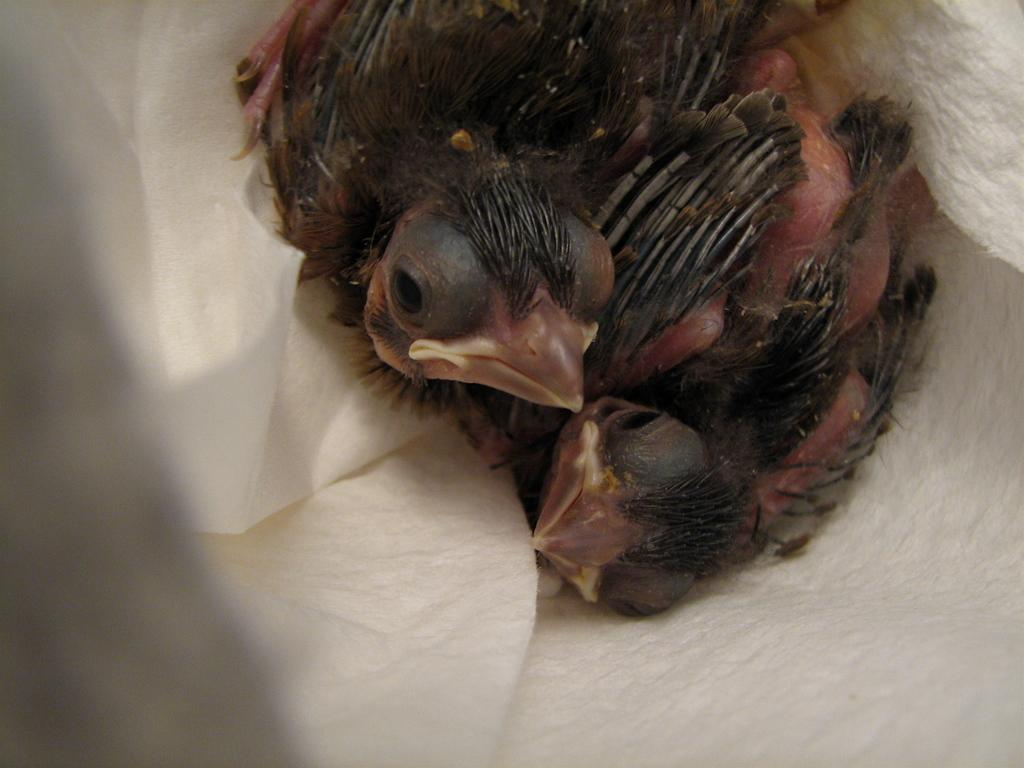What type of animal is in the image? There is a bird in the image. What color is the bird? The bird is brown in color. What is the bird standing on in the image? The bird is on a white surface. What type of drug can be seen in the image? There is no drug present in the image; it features a brown bird on a white surface. 